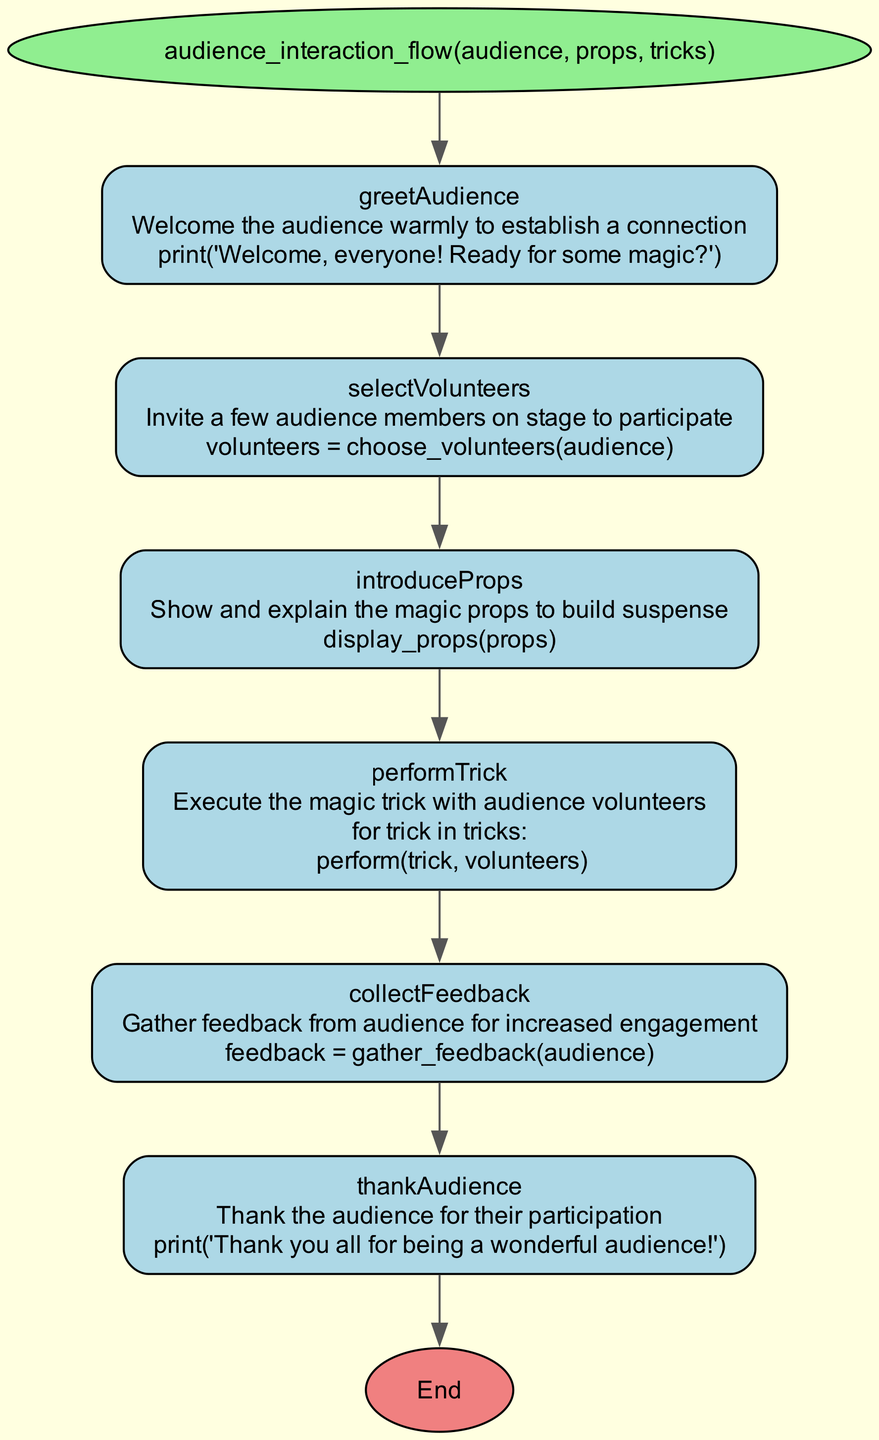What is the first step in the audience interaction flow? The first step is "greetAudience." This is identified as the first node in the flowchart, which connects to the main function node.
Answer: greetAudience How many steps are there in the audience interaction flow? There are six steps listed in the diagram, each detailing a part of the interaction process.
Answer: six What action is performed in the "introduceProps" step? The action for the "introduceProps" step is to display the props to the audience, as indicated directly under that step.
Answer: display_props(props) Which step follows "performTrick"? The next step following "performTrick" is "collectFeedback." This can be identified by following the directed edge from the "performTrick" node to the "collectFeedback" node.
Answer: collectFeedback In which step does the audience receive thanks? The audience receives thanks in the "thankAudience" step, as explicitly stated in the description of that step.
Answer: thankAudience What type of audience activity is conducted in the "selectVolunteers" step? In the "selectVolunteers" step, the activity involves inviting audience members on stage to participate, described in that step's narrative.
Answer: inviting audience members What happens after feedback is collected in the audience interaction flow? After feedback is collected in the "collectFeedback" step, the flow leads to the "thankAudience" step, indicating that gratitude is expressed thereafter.
Answer: thankAudience How does the flowchart begin? The flowchart begins with the function node labeled with the function name and parameters, serving as the starting point for the entire flow.
Answer: audience_interaction_flow(audience, props, tricks) How many nodes represent the steps of audience interaction? There are six nodes that represent the steps of audience interaction, each corresponding to a specific action taken in the flow.
Answer: six 